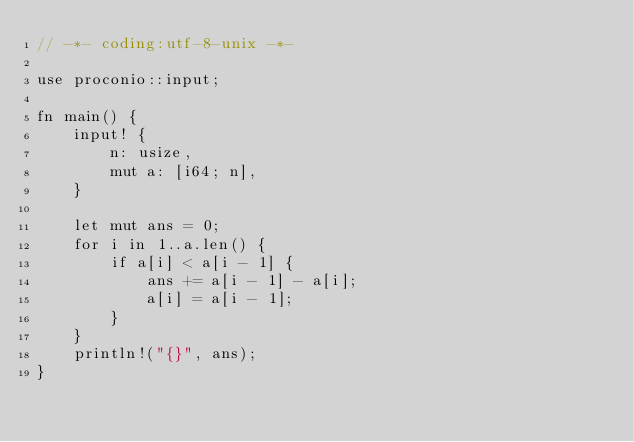<code> <loc_0><loc_0><loc_500><loc_500><_Rust_>// -*- coding:utf-8-unix -*-

use proconio::input;

fn main() {
    input! {
        n: usize,
        mut a: [i64; n],
    }

    let mut ans = 0;
    for i in 1..a.len() {
        if a[i] < a[i - 1] {
            ans += a[i - 1] - a[i];
            a[i] = a[i - 1];
        }
    }
    println!("{}", ans);
}
</code> 